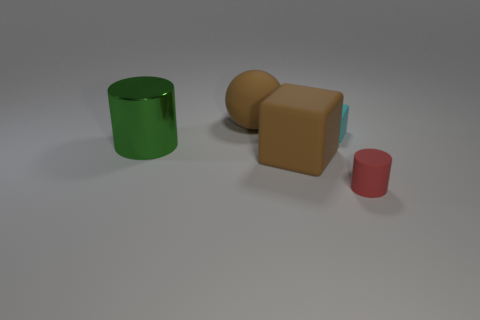Add 1 tiny cyan cubes. How many objects exist? 6 Subtract all blue spheres. Subtract all yellow cylinders. How many spheres are left? 1 Subtract all green cylinders. How many cyan cubes are left? 1 Subtract all big shiny spheres. Subtract all small red cylinders. How many objects are left? 4 Add 2 rubber cylinders. How many rubber cylinders are left? 3 Add 3 small green matte balls. How many small green matte balls exist? 3 Subtract all green cylinders. How many cylinders are left? 1 Subtract 1 brown blocks. How many objects are left? 4 Subtract all spheres. How many objects are left? 4 Subtract 1 spheres. How many spheres are left? 0 